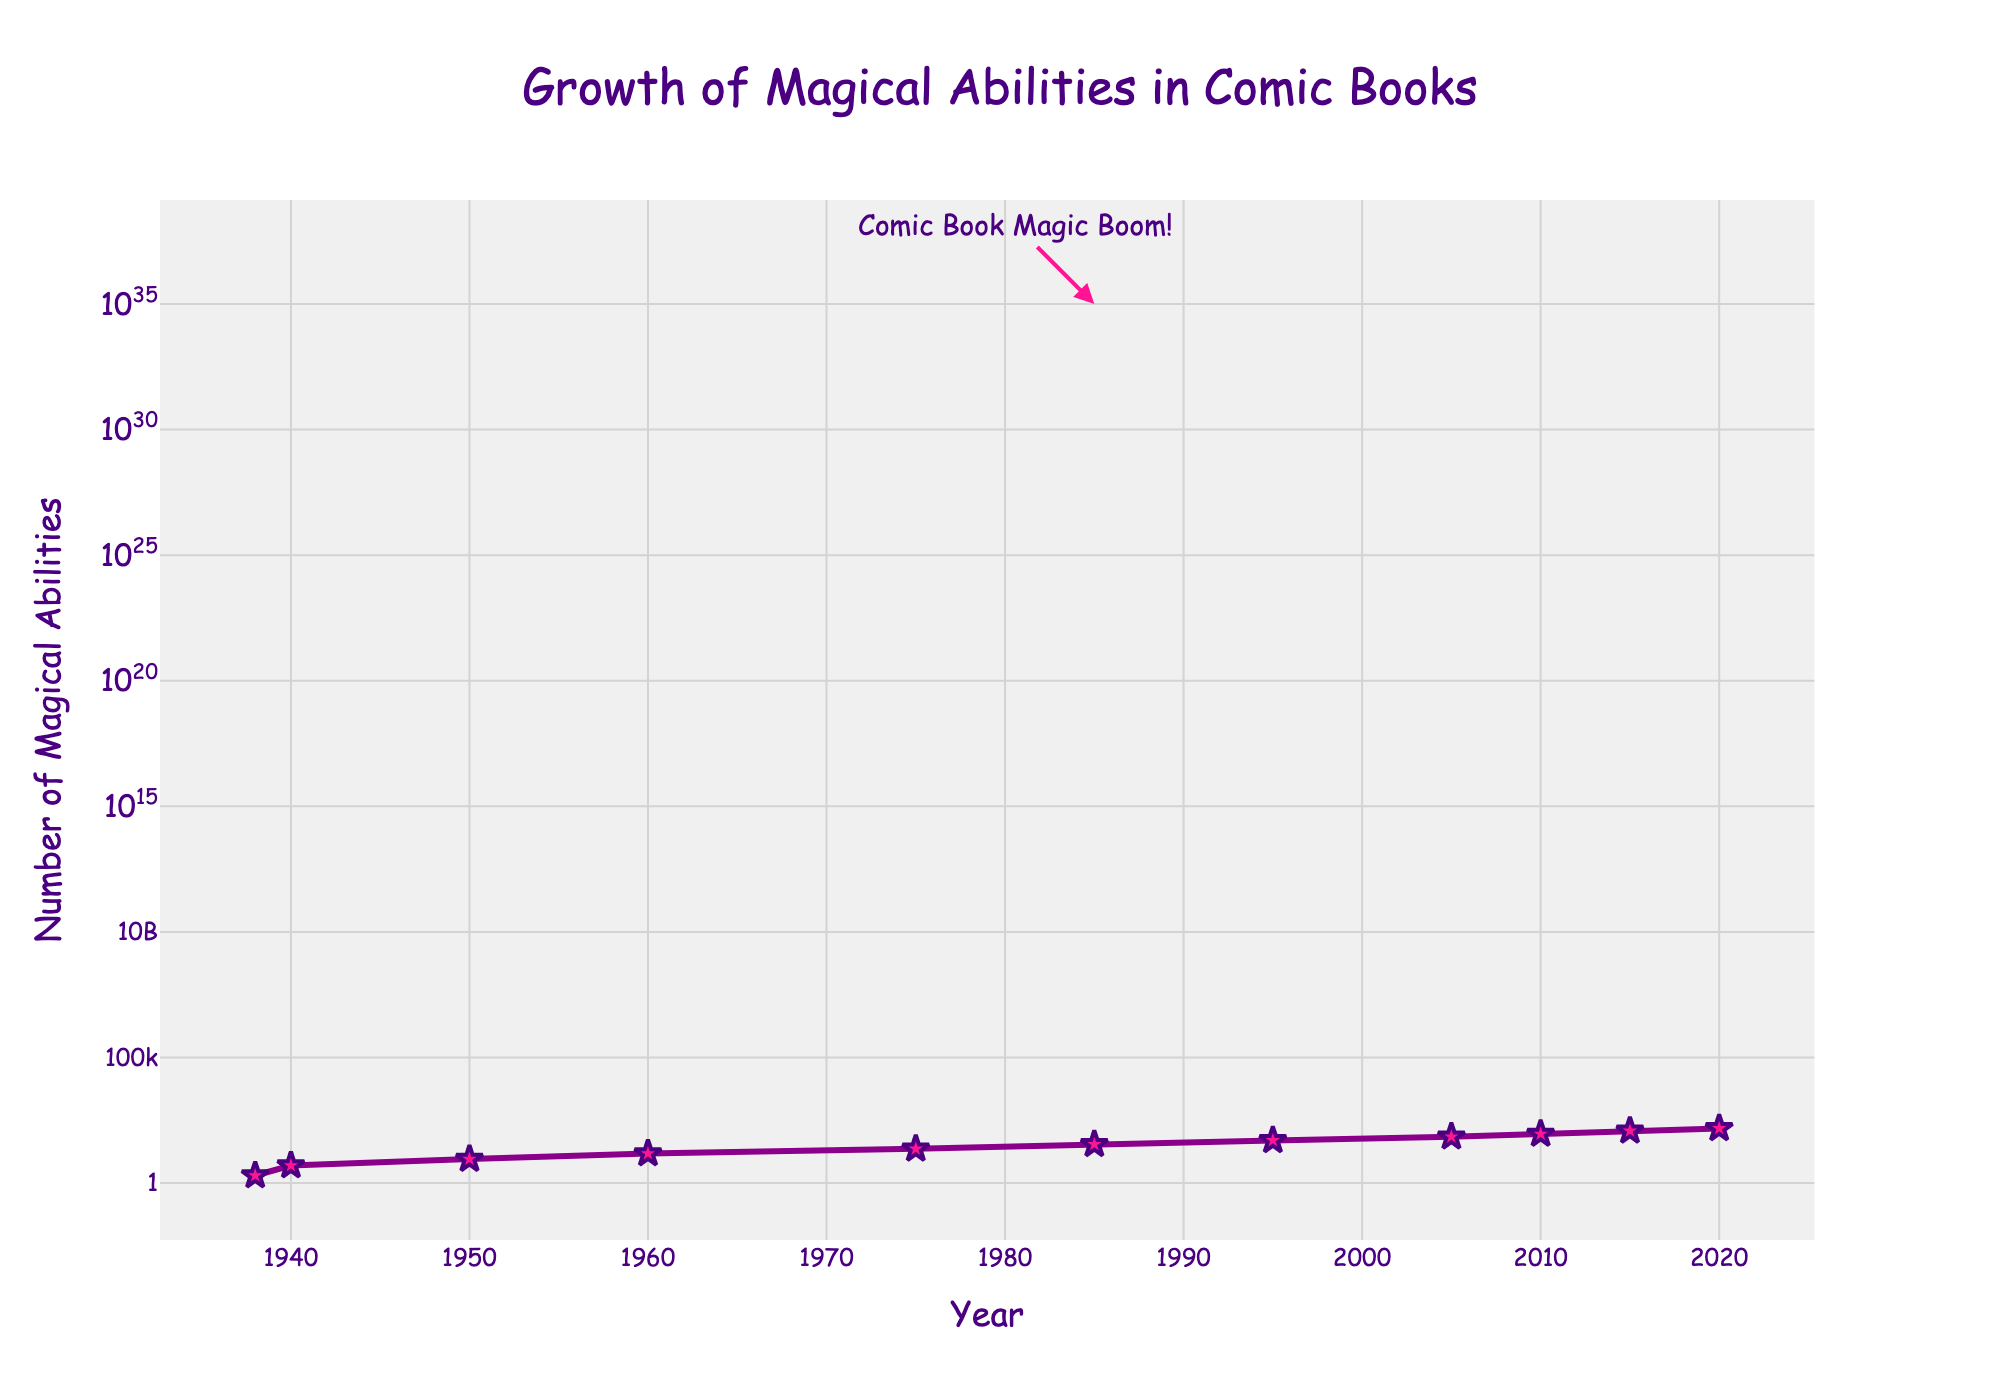What is the title of the figure? The title is usually located at the top of the figure and is formatted to stand out. The title here is "Growth of Magical Abilities in Comic Books".
Answer: Growth of Magical Abilities in Comic Books What is the color of the line representing the number of magical abilities? The color of the line can be observed directly in the plot. It appears as a distinctive purple color.
Answer: Purple What is the annotation text added to the year 1985? The annotation text is given directly in the plot around the specified year. It reads "Comic Book Magic Boom!".
Answer: Comic Book Magic Boom! How many data points are plotted in the figure? To find the number of data points, count the markers plotted on the line. There are markers at each year presented in the data set.
Answer: 11 What's the rate of growth in the number of magical abilities from 2010 to 2015? Identify the y-values for the years 2010 and 2015. Calculate the rate by dividing the difference in y-values by the difference in years: (120-90)/(2015-2010) = 30/5 = 6 abilities/year.
Answer: 6 abilities/year Which year had the number 2 for magical abilities? Look for the year corresponding to the y-value of 2. The plot shows that this occurs in the year 1938.
Answer: 1938 Between which two years did the number of magical abilities double from 50 to 100 approximately? Examine the y-values and identify years where numbers closely approximate doubling from 50 to 100. The increase happened between 1995 (50) and a bit before 2010 (near 100).
Answer: 1995 and around 2010 What does the y-axis represent and in which scale? The y-axis is labeled as "Number of Magical Abilities" and the scale is logarithmic, meaning each unit increase represents a tenfold increase.
Answer: Number of Magical Abilities, Logarithmic scale Which year witnessed the highest number of magical abilities? The y-value is the highest at 150 in the year 2020, which is the rightmost point on the plot.
Answer: 2020 How did the number of magical abilities change between 1985 and 1995? Identify the values for 1985 and 1995, and then subtract them to find the change. The number of magical abilities increased from 35 (1985) to 50 (1995), a total increase of 15.
Answer: Increased by 15 